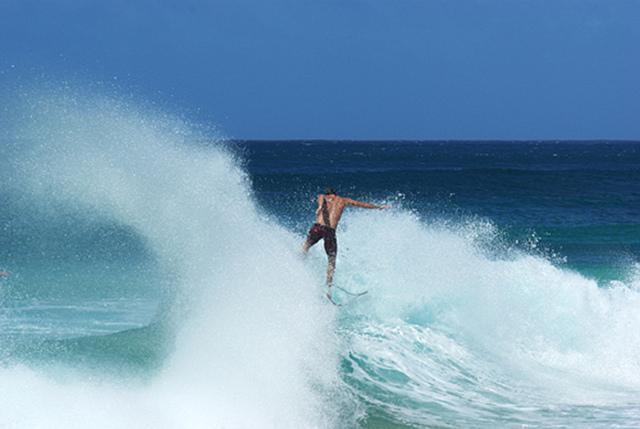How many rolls of toilet paper do you see?
Give a very brief answer. 0. 